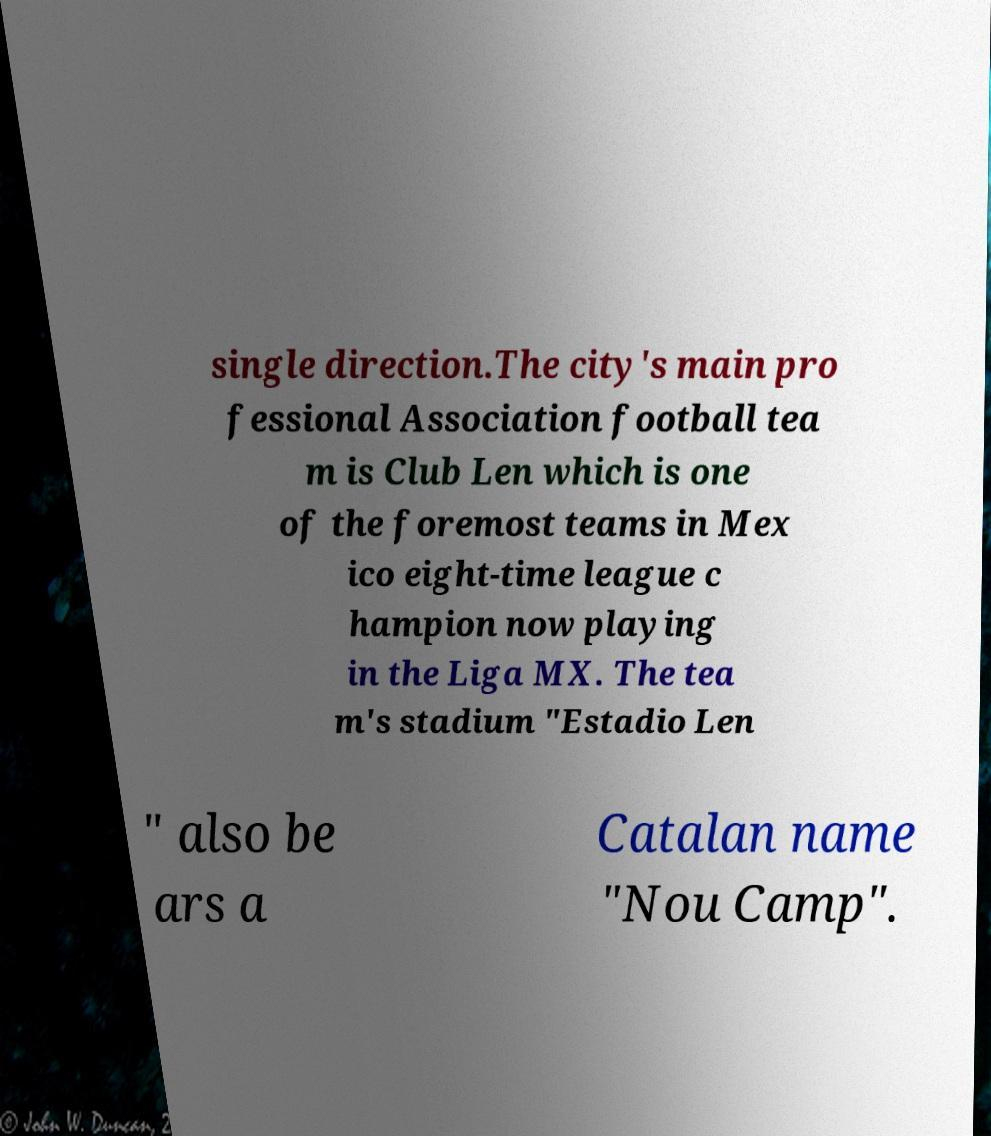For documentation purposes, I need the text within this image transcribed. Could you provide that? single direction.The city's main pro fessional Association football tea m is Club Len which is one of the foremost teams in Mex ico eight-time league c hampion now playing in the Liga MX. The tea m's stadium "Estadio Len " also be ars a Catalan name "Nou Camp". 